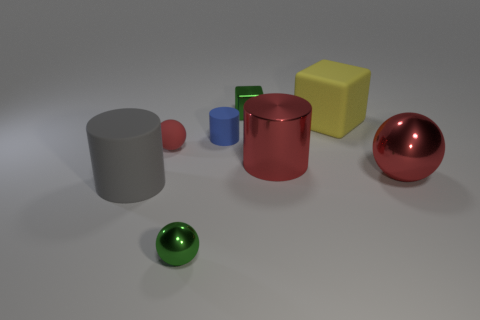There is a thing that is to the right of the large red cylinder and behind the small red sphere; what is its size?
Offer a terse response. Large. The yellow thing is what shape?
Offer a very short reply. Cube. How many objects are blue matte objects or cylinders that are in front of the big sphere?
Give a very brief answer. 2. There is a big cylinder to the right of the gray cylinder; is it the same color as the big shiny ball?
Provide a succinct answer. Yes. There is a large thing that is both right of the big gray cylinder and to the left of the large matte block; what is its color?
Your response must be concise. Red. There is a cube that is on the right side of the green block; what is its material?
Keep it short and to the point. Rubber. The metallic cube has what size?
Make the answer very short. Small. What number of yellow things are either large cylinders or large objects?
Offer a very short reply. 1. There is a matte cylinder that is on the left side of the small green shiny thing that is in front of the red rubber sphere; what is its size?
Make the answer very short. Large. Do the tiny shiny sphere and the metal thing behind the big metallic cylinder have the same color?
Offer a terse response. Yes. 